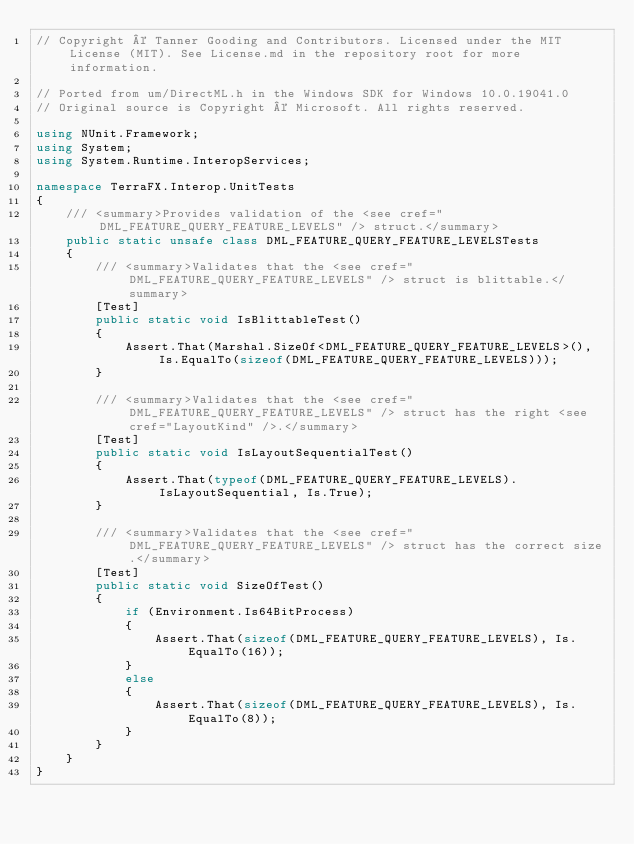<code> <loc_0><loc_0><loc_500><loc_500><_C#_>// Copyright © Tanner Gooding and Contributors. Licensed under the MIT License (MIT). See License.md in the repository root for more information.

// Ported from um/DirectML.h in the Windows SDK for Windows 10.0.19041.0
// Original source is Copyright © Microsoft. All rights reserved.

using NUnit.Framework;
using System;
using System.Runtime.InteropServices;

namespace TerraFX.Interop.UnitTests
{
    /// <summary>Provides validation of the <see cref="DML_FEATURE_QUERY_FEATURE_LEVELS" /> struct.</summary>
    public static unsafe class DML_FEATURE_QUERY_FEATURE_LEVELSTests
    {
        /// <summary>Validates that the <see cref="DML_FEATURE_QUERY_FEATURE_LEVELS" /> struct is blittable.</summary>
        [Test]
        public static void IsBlittableTest()
        {
            Assert.That(Marshal.SizeOf<DML_FEATURE_QUERY_FEATURE_LEVELS>(), Is.EqualTo(sizeof(DML_FEATURE_QUERY_FEATURE_LEVELS)));
        }

        /// <summary>Validates that the <see cref="DML_FEATURE_QUERY_FEATURE_LEVELS" /> struct has the right <see cref="LayoutKind" />.</summary>
        [Test]
        public static void IsLayoutSequentialTest()
        {
            Assert.That(typeof(DML_FEATURE_QUERY_FEATURE_LEVELS).IsLayoutSequential, Is.True);
        }

        /// <summary>Validates that the <see cref="DML_FEATURE_QUERY_FEATURE_LEVELS" /> struct has the correct size.</summary>
        [Test]
        public static void SizeOfTest()
        {
            if (Environment.Is64BitProcess)
            {
                Assert.That(sizeof(DML_FEATURE_QUERY_FEATURE_LEVELS), Is.EqualTo(16));
            }
            else
            {
                Assert.That(sizeof(DML_FEATURE_QUERY_FEATURE_LEVELS), Is.EqualTo(8));
            }
        }
    }
}
</code> 